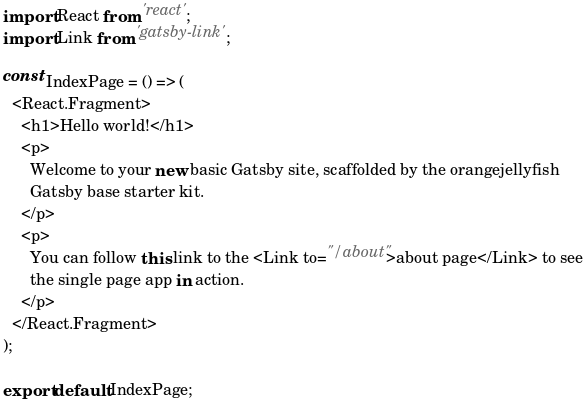Convert code to text. <code><loc_0><loc_0><loc_500><loc_500><_JavaScript_>import React from 'react';
import Link from 'gatsby-link';

const IndexPage = () => (
  <React.Fragment>
    <h1>Hello world!</h1>
    <p>
      Welcome to your new basic Gatsby site, scaffolded by the orangejellyfish
      Gatsby base starter kit.
    </p>
    <p>
      You can follow this link to the <Link to="/about">about page</Link> to see
      the single page app in action.
    </p>
  </React.Fragment>
);

export default IndexPage;
</code> 